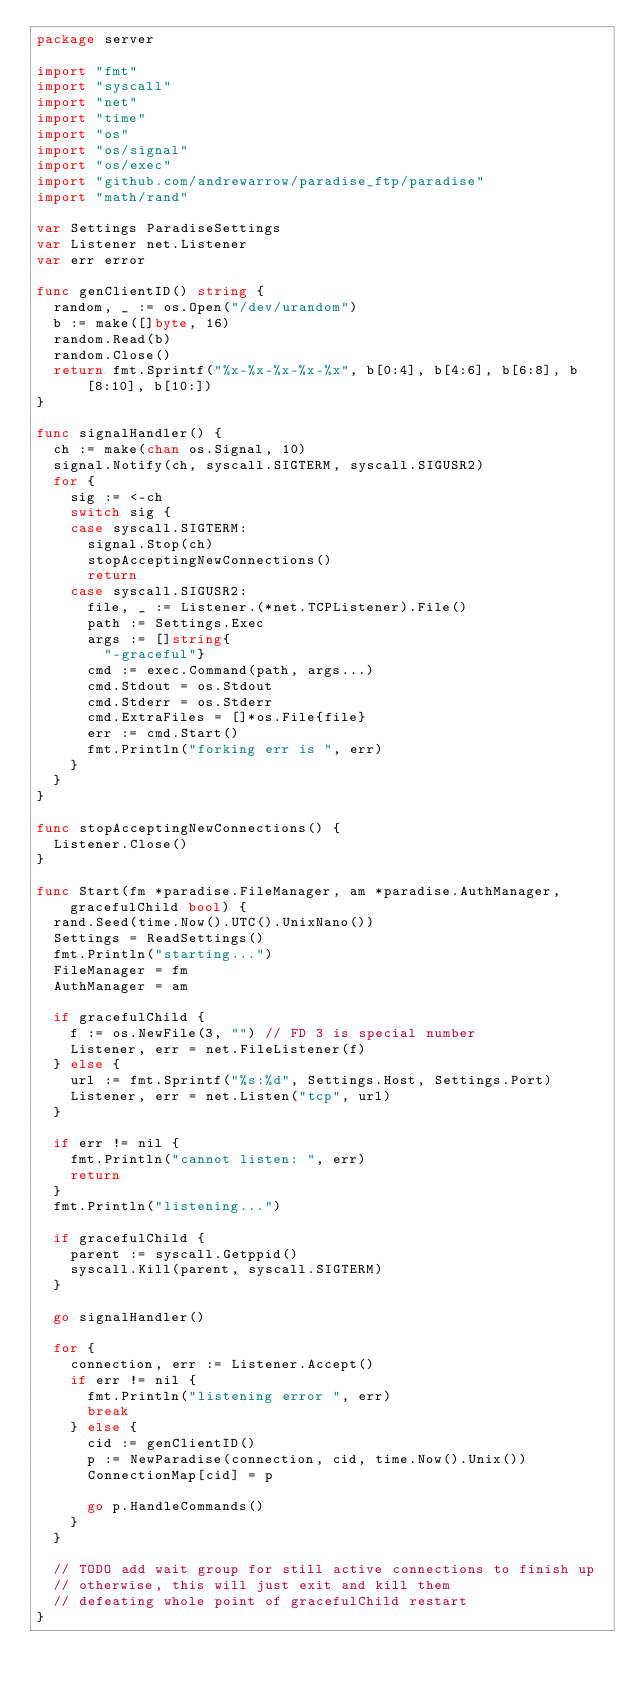<code> <loc_0><loc_0><loc_500><loc_500><_Go_>package server

import "fmt"
import "syscall"
import "net"
import "time"
import "os"
import "os/signal"
import "os/exec"
import "github.com/andrewarrow/paradise_ftp/paradise"
import "math/rand"

var Settings ParadiseSettings
var Listener net.Listener
var err error

func genClientID() string {
	random, _ := os.Open("/dev/urandom")
	b := make([]byte, 16)
	random.Read(b)
	random.Close()
	return fmt.Sprintf("%x-%x-%x-%x-%x", b[0:4], b[4:6], b[6:8], b[8:10], b[10:])
}

func signalHandler() {
	ch := make(chan os.Signal, 10)
	signal.Notify(ch, syscall.SIGTERM, syscall.SIGUSR2)
	for {
		sig := <-ch
		switch sig {
		case syscall.SIGTERM:
			signal.Stop(ch)
			stopAcceptingNewConnections()
			return
		case syscall.SIGUSR2:
			file, _ := Listener.(*net.TCPListener).File()
			path := Settings.Exec
			args := []string{
				"-graceful"}
			cmd := exec.Command(path, args...)
			cmd.Stdout = os.Stdout
			cmd.Stderr = os.Stderr
			cmd.ExtraFiles = []*os.File{file}
			err := cmd.Start()
			fmt.Println("forking err is ", err)
		}
	}
}

func stopAcceptingNewConnections() {
	Listener.Close()
}

func Start(fm *paradise.FileManager, am *paradise.AuthManager, gracefulChild bool) {
	rand.Seed(time.Now().UTC().UnixNano())
	Settings = ReadSettings()
	fmt.Println("starting...")
	FileManager = fm
	AuthManager = am

	if gracefulChild {
		f := os.NewFile(3, "") // FD 3 is special number
		Listener, err = net.FileListener(f)
	} else {
		url := fmt.Sprintf("%s:%d", Settings.Host, Settings.Port)
		Listener, err = net.Listen("tcp", url)
	}

	if err != nil {
		fmt.Println("cannot listen: ", err)
		return
	}
	fmt.Println("listening...")

	if gracefulChild {
		parent := syscall.Getppid()
		syscall.Kill(parent, syscall.SIGTERM)
	}

	go signalHandler()

	for {
		connection, err := Listener.Accept()
		if err != nil {
			fmt.Println("listening error ", err)
			break
		} else {
			cid := genClientID()
			p := NewParadise(connection, cid, time.Now().Unix())
			ConnectionMap[cid] = p

			go p.HandleCommands()
		}
	}

	// TODO add wait group for still active connections to finish up
	// otherwise, this will just exit and kill them
	// defeating whole point of gracefulChild restart
}
</code> 